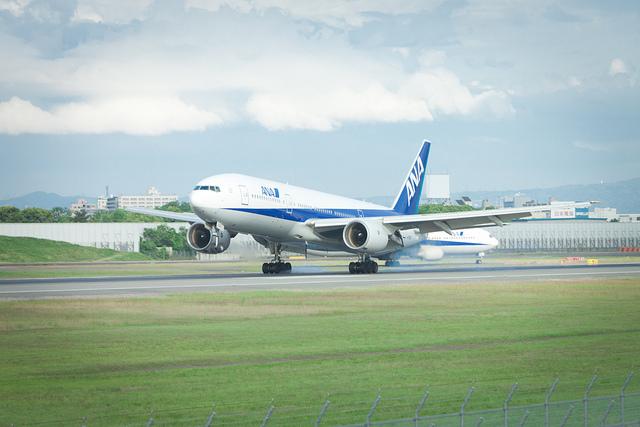How many wheels on the plane?
Short answer required. 16. Is the plan about to take off?
Short answer required. Yes. Is that a civilian plane?
Short answer required. Yes. Is the plane landing or taking off?
Keep it brief. Taking off. Is the plane at it's gate?
Quick response, please. No. What is the color of the plane?
Quick response, please. White and blue. Is the plane occupied?
Give a very brief answer. Yes. How many engines do these aircraft have?
Answer briefly. 2. What color are the stripes on this plane?
Short answer required. Blue. Is this a new airplane?
Give a very brief answer. Yes. Is it a sunny day?
Write a very short answer. Yes. How many engines are on the plane?
Answer briefly. 2. Does it have a propeller?
Answer briefly. No. How many planes are in this scene?
Short answer required. 2. Is it ready for takeoff?
Be succinct. Yes. What phase of flight is the plane in?
Write a very short answer. Takeoff. How many wheels does this plane have?
Quick response, please. 8. What is the weather in this scene?
Answer briefly. Cloudy. Is this plane grounded for good?
Concise answer only. No. How many runways are in this photo?
Quick response, please. 1. 